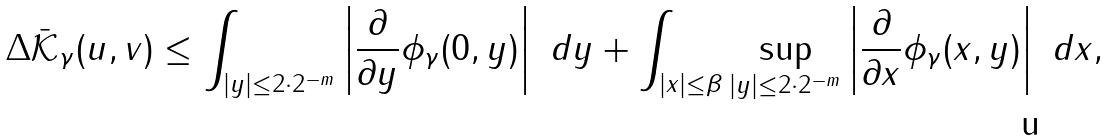Convert formula to latex. <formula><loc_0><loc_0><loc_500><loc_500>\Delta \bar { \mathcal { K } } _ { \gamma } ( u , v ) \leq \int _ { | y | \leq 2 \cdot 2 ^ { - m } } \left | \frac { \partial } { \partial y } \phi _ { \gamma } ( 0 , y ) \right | \ d y + \int _ { | x | \leq \beta } \sup _ { | y | \leq 2 \cdot 2 ^ { - m } } \left | \frac { \partial } { \partial x } \phi _ { \gamma } ( x , y ) \right | \ d x ,</formula> 